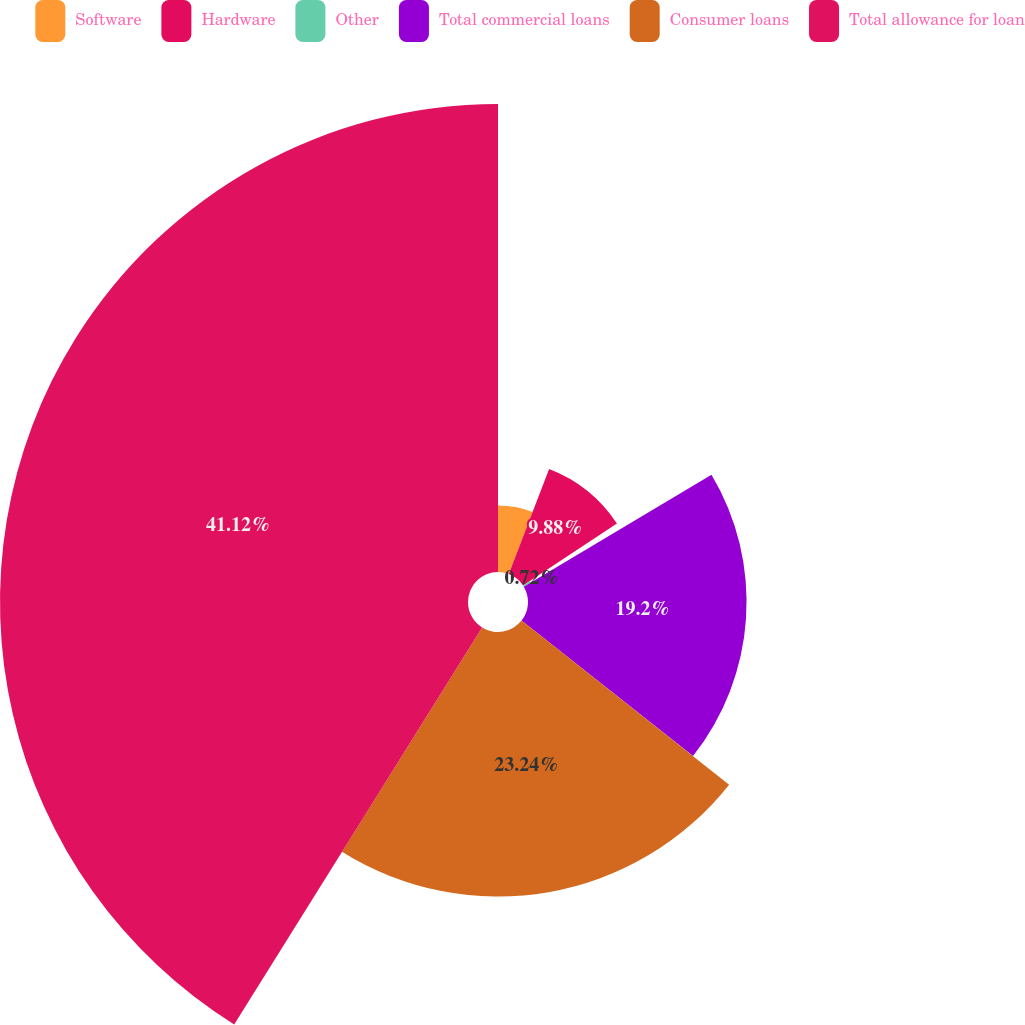<chart> <loc_0><loc_0><loc_500><loc_500><pie_chart><fcel>Software<fcel>Hardware<fcel>Other<fcel>Total commercial loans<fcel>Consumer loans<fcel>Total allowance for loan<nl><fcel>5.84%<fcel>9.88%<fcel>0.72%<fcel>19.2%<fcel>23.24%<fcel>41.11%<nl></chart> 